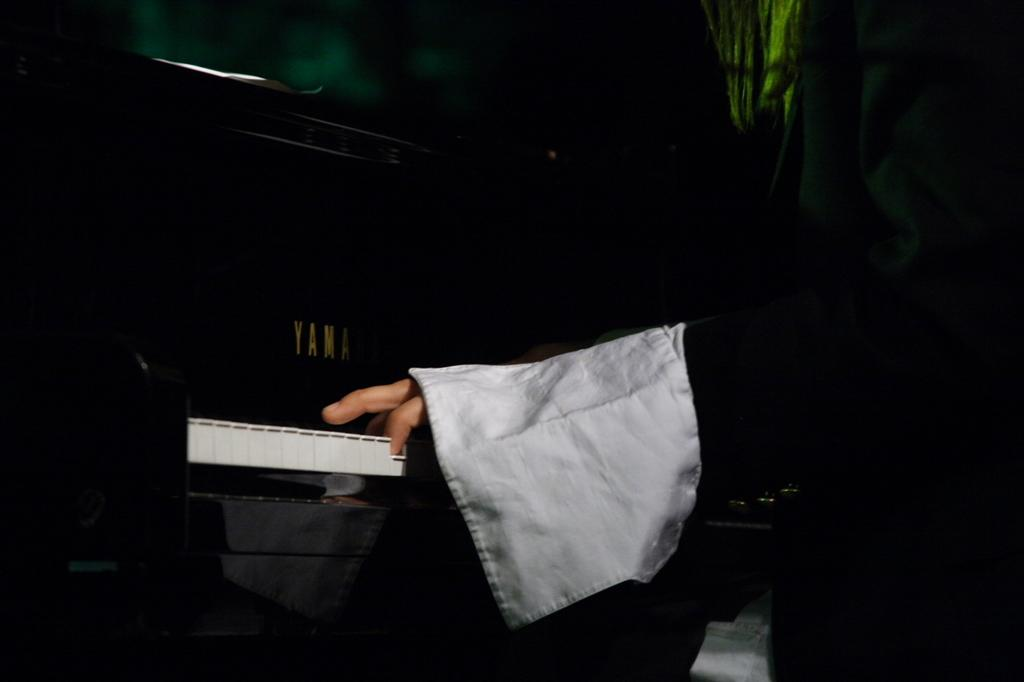What is the person in the image doing? The person is playing a piano. Is there any text or writing on the piano? Yes, something is written on the piano. Can you describe the background of the image? The background of the image is blurred. How many ants can be seen crawling on the piano keys in the image? There are no ants present in the image. What question is being asked on the piano in the image? There is no question written on the piano in the image. 